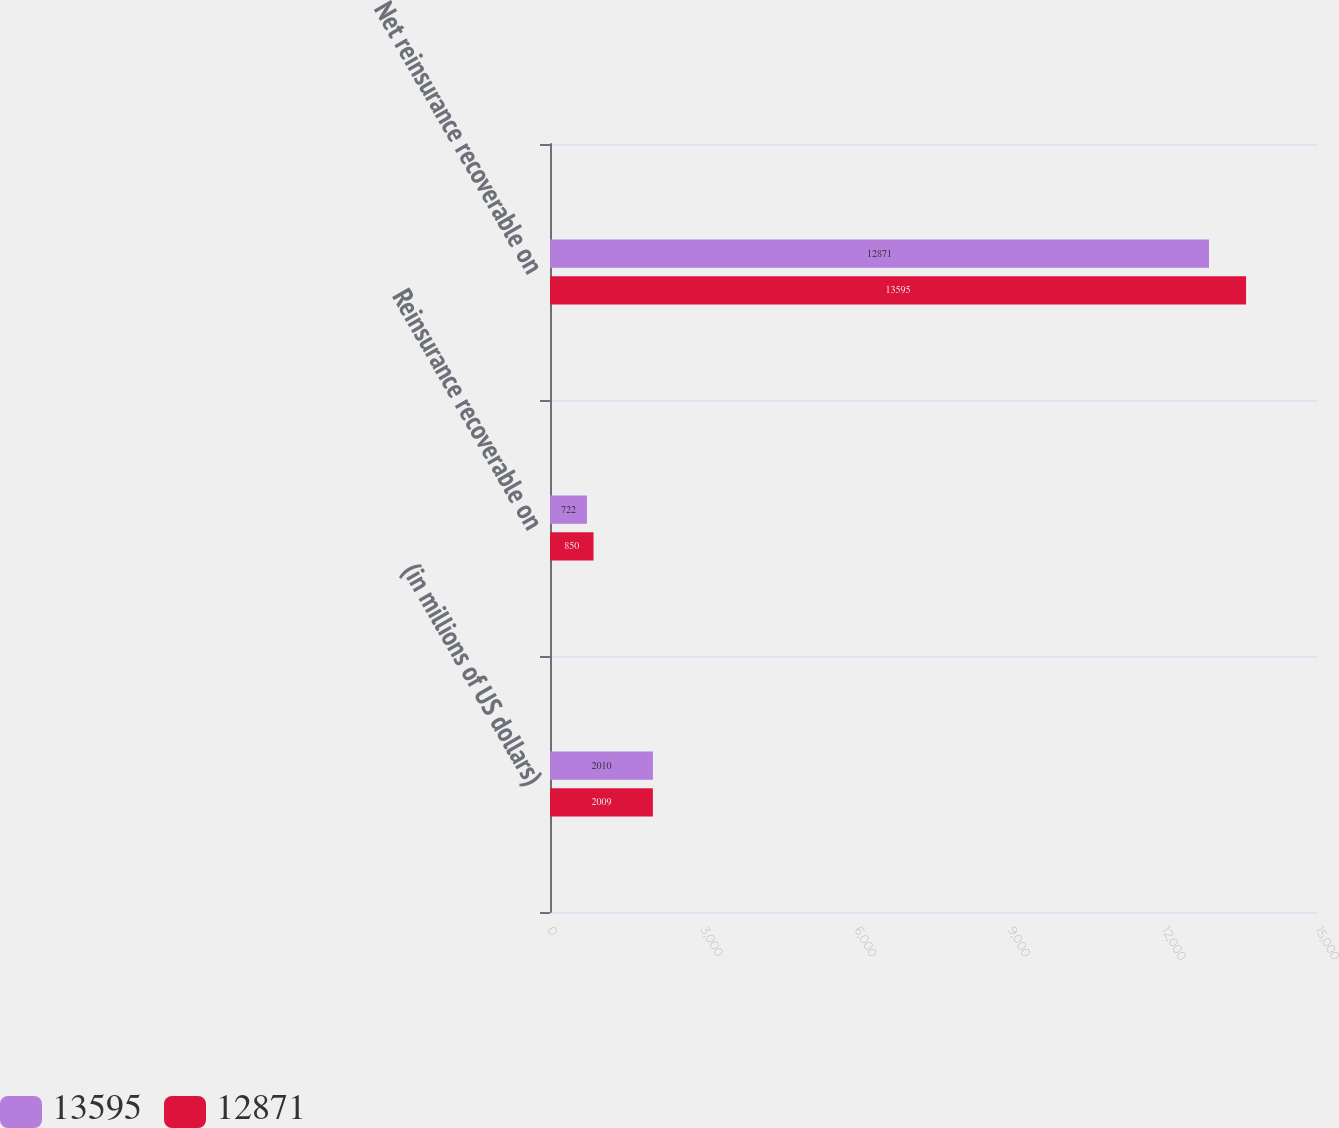Convert chart to OTSL. <chart><loc_0><loc_0><loc_500><loc_500><stacked_bar_chart><ecel><fcel>(in millions of US dollars)<fcel>Reinsurance recoverable on<fcel>Net reinsurance recoverable on<nl><fcel>13595<fcel>2010<fcel>722<fcel>12871<nl><fcel>12871<fcel>2009<fcel>850<fcel>13595<nl></chart> 